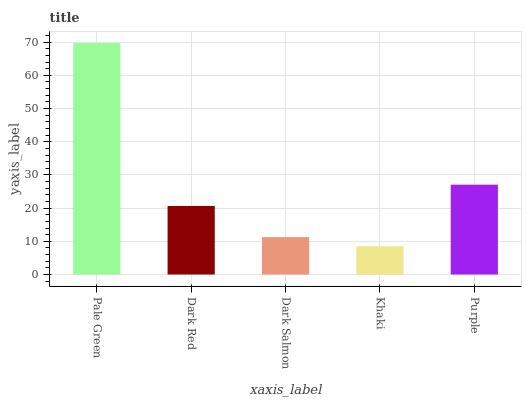Is Khaki the minimum?
Answer yes or no. Yes. Is Pale Green the maximum?
Answer yes or no. Yes. Is Dark Red the minimum?
Answer yes or no. No. Is Dark Red the maximum?
Answer yes or no. No. Is Pale Green greater than Dark Red?
Answer yes or no. Yes. Is Dark Red less than Pale Green?
Answer yes or no. Yes. Is Dark Red greater than Pale Green?
Answer yes or no. No. Is Pale Green less than Dark Red?
Answer yes or no. No. Is Dark Red the high median?
Answer yes or no. Yes. Is Dark Red the low median?
Answer yes or no. Yes. Is Khaki the high median?
Answer yes or no. No. Is Dark Salmon the low median?
Answer yes or no. No. 